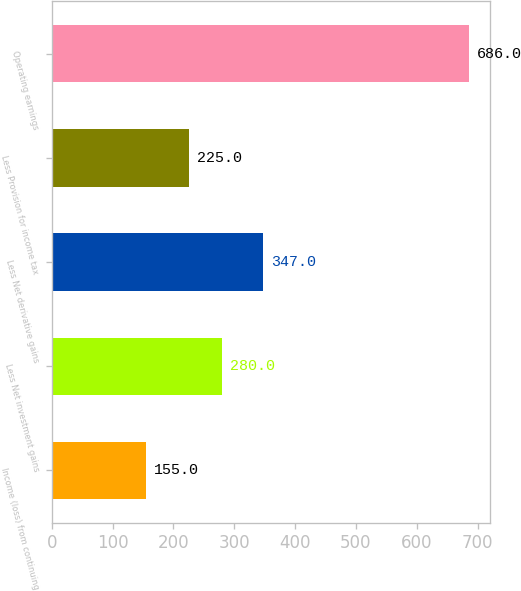<chart> <loc_0><loc_0><loc_500><loc_500><bar_chart><fcel>Income (loss) from continuing<fcel>Less Net investment gains<fcel>Less Net derivative gains<fcel>Less Provision for income tax<fcel>Operating earnings<nl><fcel>155<fcel>280<fcel>347<fcel>225<fcel>686<nl></chart> 